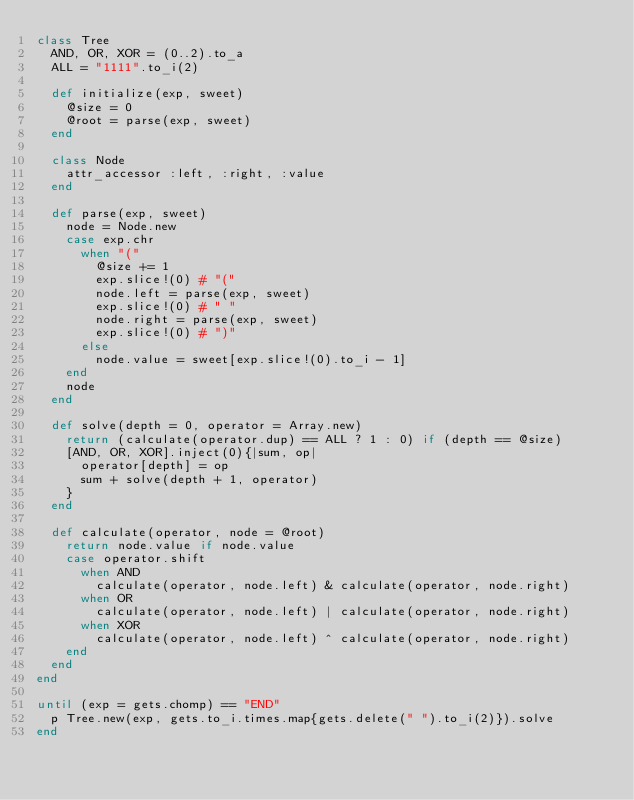<code> <loc_0><loc_0><loc_500><loc_500><_Ruby_>class Tree
  AND, OR, XOR = (0..2).to_a
  ALL = "1111".to_i(2)

  def initialize(exp, sweet)
    @size = 0
    @root = parse(exp, sweet)
  end

  class Node
    attr_accessor :left, :right, :value
  end

  def parse(exp, sweet)
    node = Node.new
    case exp.chr
      when "("
        @size += 1
        exp.slice!(0) # "("
        node.left = parse(exp, sweet)
        exp.slice!(0) # " "
        node.right = parse(exp, sweet)
        exp.slice!(0) # ")"
      else
        node.value = sweet[exp.slice!(0).to_i - 1]
    end
    node
  end

  def solve(depth = 0, operator = Array.new)
    return (calculate(operator.dup) == ALL ? 1 : 0) if (depth == @size)
    [AND, OR, XOR].inject(0){|sum, op|
      operator[depth] = op
      sum + solve(depth + 1, operator)
    }
  end

  def calculate(operator, node = @root)
    return node.value if node.value
    case operator.shift
      when AND
        calculate(operator, node.left) & calculate(operator, node.right)
      when OR
        calculate(operator, node.left) | calculate(operator, node.right)
      when XOR
        calculate(operator, node.left) ^ calculate(operator, node.right)
    end
  end
end

until (exp = gets.chomp) == "END"
  p Tree.new(exp, gets.to_i.times.map{gets.delete(" ").to_i(2)}).solve
end</code> 